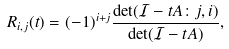Convert formula to latex. <formula><loc_0><loc_0><loc_500><loc_500>R _ { i , j } ( t ) = ( - 1 ) ^ { i + j } \frac { \det ( \mathcal { I } - t A \colon j , i ) } { \det ( \mathcal { I } - t A ) } ,</formula> 